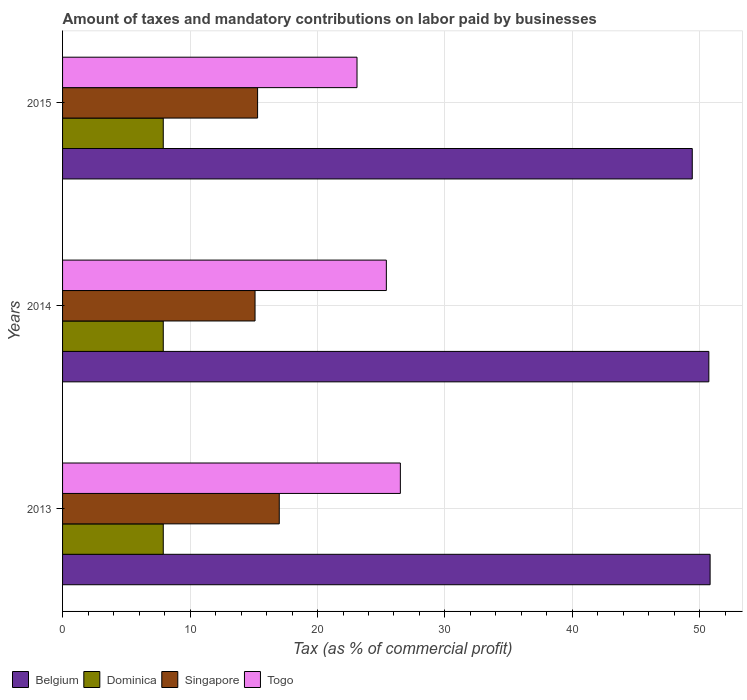How many different coloured bars are there?
Offer a terse response. 4. Are the number of bars per tick equal to the number of legend labels?
Your answer should be compact. Yes. What is the label of the 2nd group of bars from the top?
Offer a terse response. 2014. In how many cases, is the number of bars for a given year not equal to the number of legend labels?
Your answer should be compact. 0. What is the percentage of taxes paid by businesses in Belgium in 2013?
Your answer should be very brief. 50.8. Across all years, what is the maximum percentage of taxes paid by businesses in Belgium?
Your answer should be very brief. 50.8. Across all years, what is the minimum percentage of taxes paid by businesses in Singapore?
Offer a terse response. 15.1. In which year was the percentage of taxes paid by businesses in Singapore maximum?
Provide a succinct answer. 2013. In which year was the percentage of taxes paid by businesses in Singapore minimum?
Your answer should be very brief. 2014. What is the total percentage of taxes paid by businesses in Dominica in the graph?
Give a very brief answer. 23.7. What is the difference between the percentage of taxes paid by businesses in Singapore in 2014 and that in 2015?
Your answer should be very brief. -0.2. What is the difference between the percentage of taxes paid by businesses in Dominica in 2014 and the percentage of taxes paid by businesses in Belgium in 2015?
Ensure brevity in your answer.  -41.5. What is the average percentage of taxes paid by businesses in Belgium per year?
Your answer should be compact. 50.3. What is the ratio of the percentage of taxes paid by businesses in Belgium in 2013 to that in 2015?
Provide a succinct answer. 1.03. Is the percentage of taxes paid by businesses in Belgium in 2013 less than that in 2015?
Your answer should be very brief. No. What is the difference between the highest and the second highest percentage of taxes paid by businesses in Belgium?
Keep it short and to the point. 0.1. What is the difference between the highest and the lowest percentage of taxes paid by businesses in Singapore?
Offer a terse response. 1.9. In how many years, is the percentage of taxes paid by businesses in Togo greater than the average percentage of taxes paid by businesses in Togo taken over all years?
Your answer should be compact. 2. Is the sum of the percentage of taxes paid by businesses in Singapore in 2013 and 2015 greater than the maximum percentage of taxes paid by businesses in Belgium across all years?
Offer a terse response. No. Is it the case that in every year, the sum of the percentage of taxes paid by businesses in Dominica and percentage of taxes paid by businesses in Singapore is greater than the sum of percentage of taxes paid by businesses in Belgium and percentage of taxes paid by businesses in Togo?
Your response must be concise. No. What does the 2nd bar from the top in 2014 represents?
Make the answer very short. Singapore. What does the 4th bar from the bottom in 2015 represents?
Provide a succinct answer. Togo. Is it the case that in every year, the sum of the percentage of taxes paid by businesses in Belgium and percentage of taxes paid by businesses in Dominica is greater than the percentage of taxes paid by businesses in Singapore?
Your answer should be compact. Yes. How many bars are there?
Provide a succinct answer. 12. What is the difference between two consecutive major ticks on the X-axis?
Offer a terse response. 10. Does the graph contain any zero values?
Your answer should be very brief. No. How many legend labels are there?
Your response must be concise. 4. How are the legend labels stacked?
Keep it short and to the point. Horizontal. What is the title of the graph?
Provide a short and direct response. Amount of taxes and mandatory contributions on labor paid by businesses. What is the label or title of the X-axis?
Your answer should be very brief. Tax (as % of commercial profit). What is the label or title of the Y-axis?
Keep it short and to the point. Years. What is the Tax (as % of commercial profit) in Belgium in 2013?
Keep it short and to the point. 50.8. What is the Tax (as % of commercial profit) in Dominica in 2013?
Keep it short and to the point. 7.9. What is the Tax (as % of commercial profit) of Togo in 2013?
Offer a terse response. 26.5. What is the Tax (as % of commercial profit) of Belgium in 2014?
Make the answer very short. 50.7. What is the Tax (as % of commercial profit) in Dominica in 2014?
Keep it short and to the point. 7.9. What is the Tax (as % of commercial profit) in Singapore in 2014?
Provide a short and direct response. 15.1. What is the Tax (as % of commercial profit) of Togo in 2014?
Provide a short and direct response. 25.4. What is the Tax (as % of commercial profit) of Belgium in 2015?
Offer a terse response. 49.4. What is the Tax (as % of commercial profit) of Singapore in 2015?
Keep it short and to the point. 15.3. What is the Tax (as % of commercial profit) of Togo in 2015?
Provide a short and direct response. 23.1. Across all years, what is the maximum Tax (as % of commercial profit) of Belgium?
Your answer should be compact. 50.8. Across all years, what is the maximum Tax (as % of commercial profit) of Togo?
Provide a short and direct response. 26.5. Across all years, what is the minimum Tax (as % of commercial profit) in Belgium?
Provide a short and direct response. 49.4. Across all years, what is the minimum Tax (as % of commercial profit) in Dominica?
Your answer should be compact. 7.9. Across all years, what is the minimum Tax (as % of commercial profit) of Singapore?
Provide a succinct answer. 15.1. Across all years, what is the minimum Tax (as % of commercial profit) of Togo?
Make the answer very short. 23.1. What is the total Tax (as % of commercial profit) of Belgium in the graph?
Ensure brevity in your answer.  150.9. What is the total Tax (as % of commercial profit) of Dominica in the graph?
Make the answer very short. 23.7. What is the total Tax (as % of commercial profit) of Singapore in the graph?
Your answer should be compact. 47.4. What is the total Tax (as % of commercial profit) in Togo in the graph?
Ensure brevity in your answer.  75. What is the difference between the Tax (as % of commercial profit) of Singapore in 2013 and that in 2014?
Provide a succinct answer. 1.9. What is the difference between the Tax (as % of commercial profit) of Dominica in 2013 and that in 2015?
Provide a short and direct response. 0. What is the difference between the Tax (as % of commercial profit) in Singapore in 2013 and that in 2015?
Your response must be concise. 1.7. What is the difference between the Tax (as % of commercial profit) of Togo in 2013 and that in 2015?
Offer a very short reply. 3.4. What is the difference between the Tax (as % of commercial profit) in Belgium in 2014 and that in 2015?
Provide a succinct answer. 1.3. What is the difference between the Tax (as % of commercial profit) of Dominica in 2014 and that in 2015?
Your answer should be very brief. 0. What is the difference between the Tax (as % of commercial profit) of Togo in 2014 and that in 2015?
Offer a very short reply. 2.3. What is the difference between the Tax (as % of commercial profit) in Belgium in 2013 and the Tax (as % of commercial profit) in Dominica in 2014?
Give a very brief answer. 42.9. What is the difference between the Tax (as % of commercial profit) of Belgium in 2013 and the Tax (as % of commercial profit) of Singapore in 2014?
Your answer should be very brief. 35.7. What is the difference between the Tax (as % of commercial profit) of Belgium in 2013 and the Tax (as % of commercial profit) of Togo in 2014?
Your answer should be very brief. 25.4. What is the difference between the Tax (as % of commercial profit) of Dominica in 2013 and the Tax (as % of commercial profit) of Togo in 2014?
Your response must be concise. -17.5. What is the difference between the Tax (as % of commercial profit) in Singapore in 2013 and the Tax (as % of commercial profit) in Togo in 2014?
Keep it short and to the point. -8.4. What is the difference between the Tax (as % of commercial profit) in Belgium in 2013 and the Tax (as % of commercial profit) in Dominica in 2015?
Give a very brief answer. 42.9. What is the difference between the Tax (as % of commercial profit) of Belgium in 2013 and the Tax (as % of commercial profit) of Singapore in 2015?
Your answer should be very brief. 35.5. What is the difference between the Tax (as % of commercial profit) of Belgium in 2013 and the Tax (as % of commercial profit) of Togo in 2015?
Give a very brief answer. 27.7. What is the difference between the Tax (as % of commercial profit) in Dominica in 2013 and the Tax (as % of commercial profit) in Togo in 2015?
Provide a short and direct response. -15.2. What is the difference between the Tax (as % of commercial profit) of Singapore in 2013 and the Tax (as % of commercial profit) of Togo in 2015?
Your answer should be compact. -6.1. What is the difference between the Tax (as % of commercial profit) in Belgium in 2014 and the Tax (as % of commercial profit) in Dominica in 2015?
Ensure brevity in your answer.  42.8. What is the difference between the Tax (as % of commercial profit) in Belgium in 2014 and the Tax (as % of commercial profit) in Singapore in 2015?
Provide a succinct answer. 35.4. What is the difference between the Tax (as % of commercial profit) of Belgium in 2014 and the Tax (as % of commercial profit) of Togo in 2015?
Provide a succinct answer. 27.6. What is the difference between the Tax (as % of commercial profit) of Dominica in 2014 and the Tax (as % of commercial profit) of Singapore in 2015?
Your answer should be very brief. -7.4. What is the difference between the Tax (as % of commercial profit) of Dominica in 2014 and the Tax (as % of commercial profit) of Togo in 2015?
Provide a short and direct response. -15.2. What is the difference between the Tax (as % of commercial profit) of Singapore in 2014 and the Tax (as % of commercial profit) of Togo in 2015?
Provide a short and direct response. -8. What is the average Tax (as % of commercial profit) of Belgium per year?
Offer a very short reply. 50.3. What is the average Tax (as % of commercial profit) of Singapore per year?
Provide a succinct answer. 15.8. What is the average Tax (as % of commercial profit) in Togo per year?
Ensure brevity in your answer.  25. In the year 2013, what is the difference between the Tax (as % of commercial profit) of Belgium and Tax (as % of commercial profit) of Dominica?
Your response must be concise. 42.9. In the year 2013, what is the difference between the Tax (as % of commercial profit) of Belgium and Tax (as % of commercial profit) of Singapore?
Give a very brief answer. 33.8. In the year 2013, what is the difference between the Tax (as % of commercial profit) in Belgium and Tax (as % of commercial profit) in Togo?
Offer a very short reply. 24.3. In the year 2013, what is the difference between the Tax (as % of commercial profit) of Dominica and Tax (as % of commercial profit) of Togo?
Offer a terse response. -18.6. In the year 2014, what is the difference between the Tax (as % of commercial profit) in Belgium and Tax (as % of commercial profit) in Dominica?
Keep it short and to the point. 42.8. In the year 2014, what is the difference between the Tax (as % of commercial profit) in Belgium and Tax (as % of commercial profit) in Singapore?
Ensure brevity in your answer.  35.6. In the year 2014, what is the difference between the Tax (as % of commercial profit) of Belgium and Tax (as % of commercial profit) of Togo?
Provide a short and direct response. 25.3. In the year 2014, what is the difference between the Tax (as % of commercial profit) in Dominica and Tax (as % of commercial profit) in Togo?
Provide a succinct answer. -17.5. In the year 2014, what is the difference between the Tax (as % of commercial profit) in Singapore and Tax (as % of commercial profit) in Togo?
Ensure brevity in your answer.  -10.3. In the year 2015, what is the difference between the Tax (as % of commercial profit) of Belgium and Tax (as % of commercial profit) of Dominica?
Your response must be concise. 41.5. In the year 2015, what is the difference between the Tax (as % of commercial profit) of Belgium and Tax (as % of commercial profit) of Singapore?
Your response must be concise. 34.1. In the year 2015, what is the difference between the Tax (as % of commercial profit) in Belgium and Tax (as % of commercial profit) in Togo?
Ensure brevity in your answer.  26.3. In the year 2015, what is the difference between the Tax (as % of commercial profit) of Dominica and Tax (as % of commercial profit) of Singapore?
Keep it short and to the point. -7.4. In the year 2015, what is the difference between the Tax (as % of commercial profit) in Dominica and Tax (as % of commercial profit) in Togo?
Your answer should be compact. -15.2. What is the ratio of the Tax (as % of commercial profit) in Belgium in 2013 to that in 2014?
Your answer should be very brief. 1. What is the ratio of the Tax (as % of commercial profit) of Dominica in 2013 to that in 2014?
Provide a succinct answer. 1. What is the ratio of the Tax (as % of commercial profit) in Singapore in 2013 to that in 2014?
Your answer should be very brief. 1.13. What is the ratio of the Tax (as % of commercial profit) of Togo in 2013 to that in 2014?
Your answer should be very brief. 1.04. What is the ratio of the Tax (as % of commercial profit) of Belgium in 2013 to that in 2015?
Keep it short and to the point. 1.03. What is the ratio of the Tax (as % of commercial profit) in Togo in 2013 to that in 2015?
Your response must be concise. 1.15. What is the ratio of the Tax (as % of commercial profit) in Belgium in 2014 to that in 2015?
Provide a succinct answer. 1.03. What is the ratio of the Tax (as % of commercial profit) of Singapore in 2014 to that in 2015?
Your answer should be compact. 0.99. What is the ratio of the Tax (as % of commercial profit) in Togo in 2014 to that in 2015?
Ensure brevity in your answer.  1.1. What is the difference between the highest and the lowest Tax (as % of commercial profit) of Togo?
Ensure brevity in your answer.  3.4. 